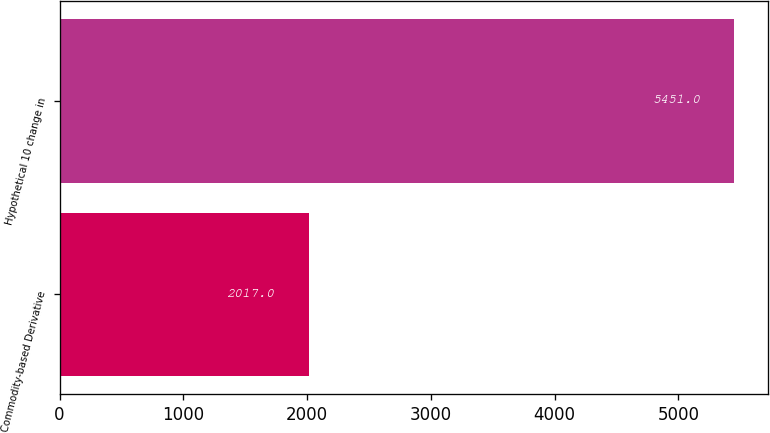<chart> <loc_0><loc_0><loc_500><loc_500><bar_chart><fcel>Commodity-based Derivative<fcel>Hypothetical 10 change in<nl><fcel>2017<fcel>5451<nl></chart> 